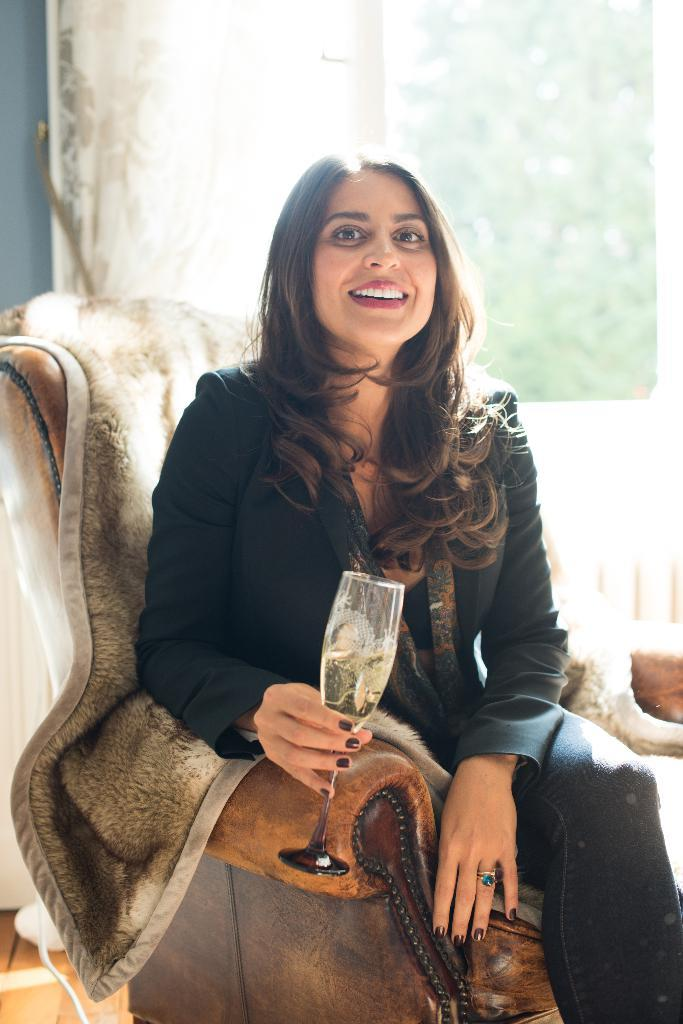Who is present in the image? There is a woman in the image. What is the woman doing in the image? The woman is sitting on a sofa and smiling. What is the woman holding in the image? The woman is holding a glass. What can be seen in the background of the image? There is a curtain in the background of the image. What type of chalk is the woman using to draw on the floor in the image? There is no chalk or drawing on the floor present in the image. How many cars can be seen in the image? There are no cars visible in the image. 